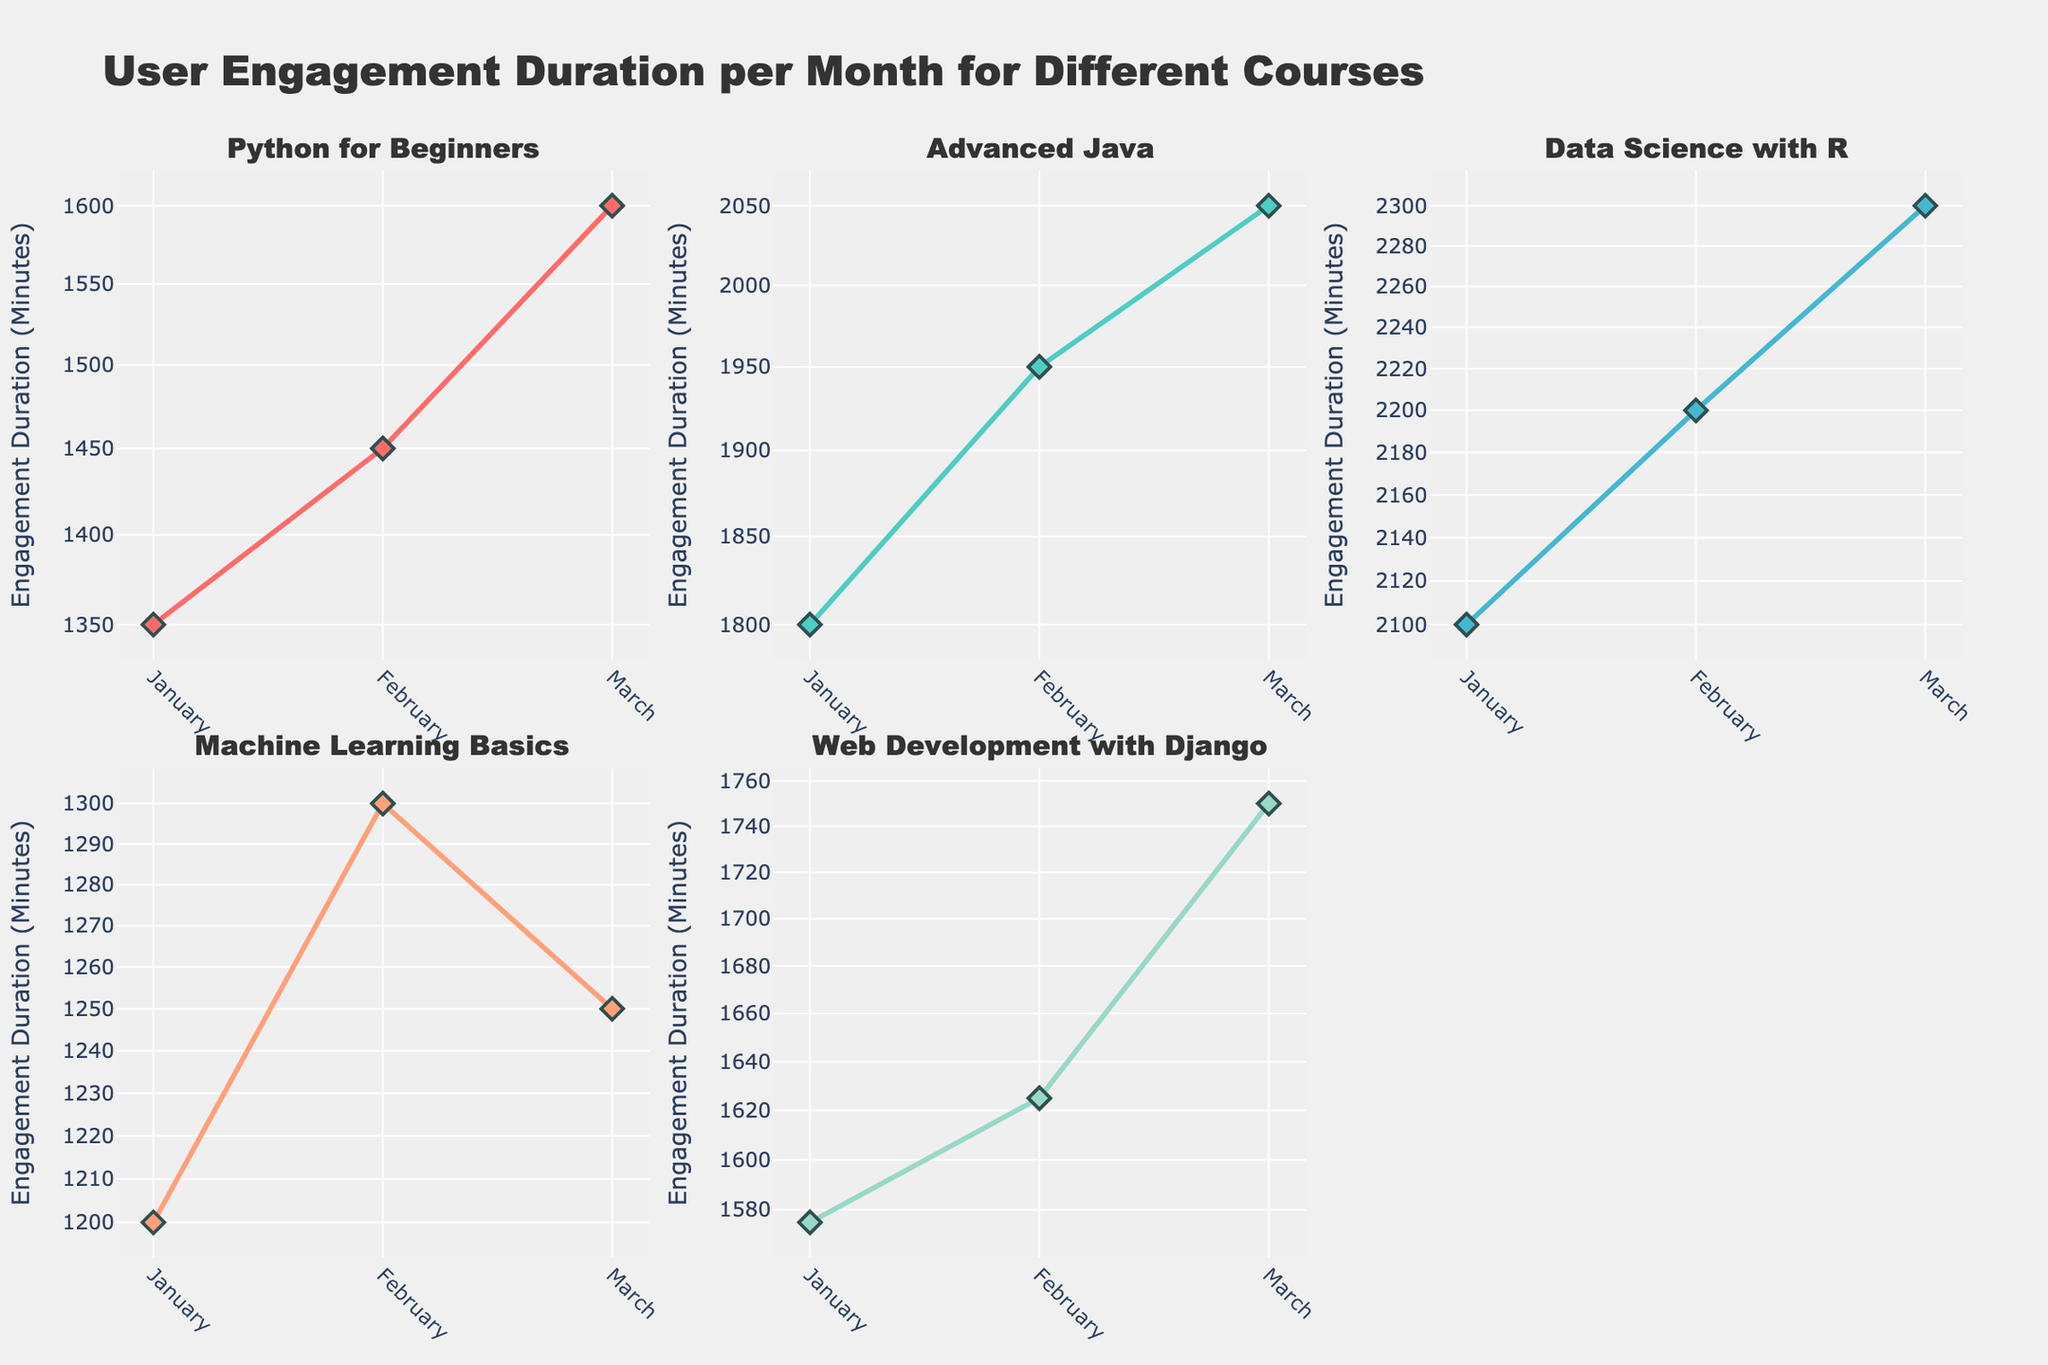What's the title of the figure? Look at the top center of the figure where titles usually are placed. The title is given as part of the plot layout.
Answer: User Engagement Duration per Month for Different Courses How many courses are shown in the subplots? Each subplot corresponds to a course, and the subplot titles should provide this information. Count the unique subplot titles.
Answer: 5 Which course has the highest engagement duration in January? Compare the January data points across all courses. Identify the highest value by comparing the heights of the markers/bars.
Answer: Data Science with R How does the engagement duration of "Machine Learning Basics" in February compare to its March values? Look at the "Machine Learning Basics" subplot and compare the February and March engagement durations by checking the corresponding data points on the plot.
Answer: February is higher What is the average engagement duration in March for all courses? Sum the engagement durations for all courses in March and divide by the number of courses. Values: Python for Beginners (1600), Advanced Java (2050), Data Science with R (2300), Machine Learning Basics (1250), Web Development with Django (1750). Calculate the average: (1600 + 2050 + 2300 + 1250 + 1750) / 5.
Answer: 1790 Which course shows the most consistent engagement duration across all three months? Assess the spread of the engagement duration values across months for each course. The course with the smallest variation (difference between the maximum and minimum values) is the most consistent.
Answer: Web Development with Django What's the general trend of engagement duration for "Advanced Java"? Observe the slope and direction of the line in the "Advanced Java" subplot. If it generally increases, the trend is upward, and vice versa.
Answer: Upward trend Do all courses have increasing engagement duration values from January to March? Examine each subplot. Check if all courses' engagement durations increase from January to March. Identify any that do not follow this trend.
Answer: No, "Machine Learning Basics" does not How does "Python for Beginners" engagement duration in February compare with "Advanced Java" in the same month? Look at the February data points for the two courses and compare their heights.
Answer: "Advanced Java" is higher What is the range of engagement durations for "Data Science with R" across all months? Identify the maximum and minimum values for this course across January, February, and March. Compute the difference between these values.
Answer: 2300 - 2100 = 200 